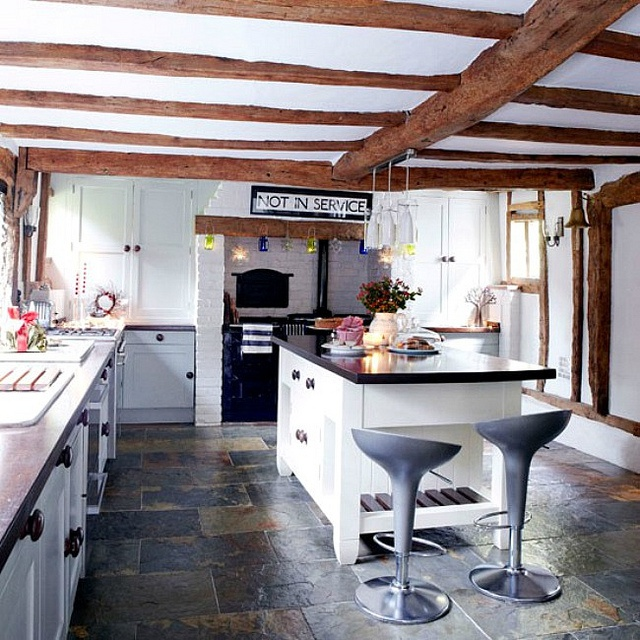Describe the objects in this image and their specific colors. I can see dining table in white, darkgray, black, and gray tones, chair in white, gray, darkgray, and lightgray tones, chair in white, gray, black, and darkgray tones, oven in white, black, lightgray, navy, and gray tones, and potted plant in white, black, gray, and maroon tones in this image. 